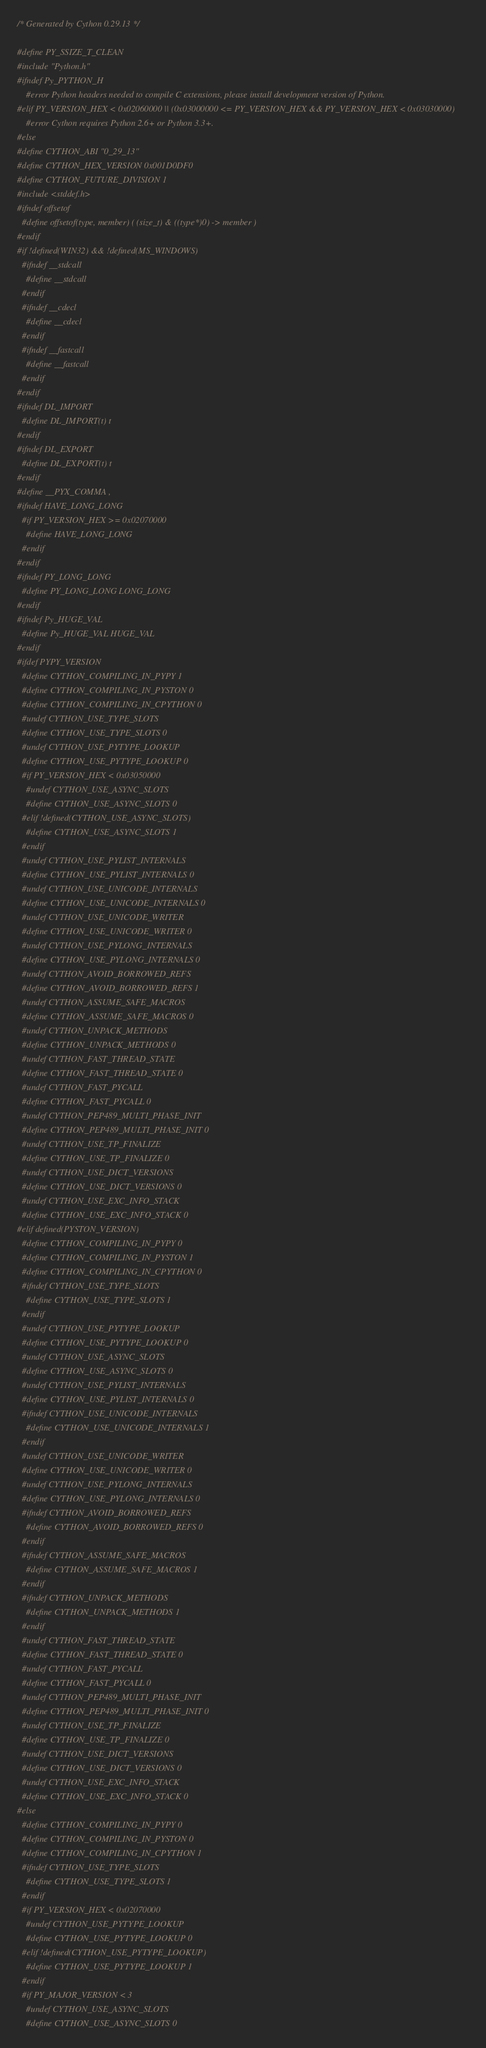Convert code to text. <code><loc_0><loc_0><loc_500><loc_500><_C_>/* Generated by Cython 0.29.13 */

#define PY_SSIZE_T_CLEAN
#include "Python.h"
#ifndef Py_PYTHON_H
    #error Python headers needed to compile C extensions, please install development version of Python.
#elif PY_VERSION_HEX < 0x02060000 || (0x03000000 <= PY_VERSION_HEX && PY_VERSION_HEX < 0x03030000)
    #error Cython requires Python 2.6+ or Python 3.3+.
#else
#define CYTHON_ABI "0_29_13"
#define CYTHON_HEX_VERSION 0x001D0DF0
#define CYTHON_FUTURE_DIVISION 1
#include <stddef.h>
#ifndef offsetof
  #define offsetof(type, member) ( (size_t) & ((type*)0) -> member )
#endif
#if !defined(WIN32) && !defined(MS_WINDOWS)
  #ifndef __stdcall
    #define __stdcall
  #endif
  #ifndef __cdecl
    #define __cdecl
  #endif
  #ifndef __fastcall
    #define __fastcall
  #endif
#endif
#ifndef DL_IMPORT
  #define DL_IMPORT(t) t
#endif
#ifndef DL_EXPORT
  #define DL_EXPORT(t) t
#endif
#define __PYX_COMMA ,
#ifndef HAVE_LONG_LONG
  #if PY_VERSION_HEX >= 0x02070000
    #define HAVE_LONG_LONG
  #endif
#endif
#ifndef PY_LONG_LONG
  #define PY_LONG_LONG LONG_LONG
#endif
#ifndef Py_HUGE_VAL
  #define Py_HUGE_VAL HUGE_VAL
#endif
#ifdef PYPY_VERSION
  #define CYTHON_COMPILING_IN_PYPY 1
  #define CYTHON_COMPILING_IN_PYSTON 0
  #define CYTHON_COMPILING_IN_CPYTHON 0
  #undef CYTHON_USE_TYPE_SLOTS
  #define CYTHON_USE_TYPE_SLOTS 0
  #undef CYTHON_USE_PYTYPE_LOOKUP
  #define CYTHON_USE_PYTYPE_LOOKUP 0
  #if PY_VERSION_HEX < 0x03050000
    #undef CYTHON_USE_ASYNC_SLOTS
    #define CYTHON_USE_ASYNC_SLOTS 0
  #elif !defined(CYTHON_USE_ASYNC_SLOTS)
    #define CYTHON_USE_ASYNC_SLOTS 1
  #endif
  #undef CYTHON_USE_PYLIST_INTERNALS
  #define CYTHON_USE_PYLIST_INTERNALS 0
  #undef CYTHON_USE_UNICODE_INTERNALS
  #define CYTHON_USE_UNICODE_INTERNALS 0
  #undef CYTHON_USE_UNICODE_WRITER
  #define CYTHON_USE_UNICODE_WRITER 0
  #undef CYTHON_USE_PYLONG_INTERNALS
  #define CYTHON_USE_PYLONG_INTERNALS 0
  #undef CYTHON_AVOID_BORROWED_REFS
  #define CYTHON_AVOID_BORROWED_REFS 1
  #undef CYTHON_ASSUME_SAFE_MACROS
  #define CYTHON_ASSUME_SAFE_MACROS 0
  #undef CYTHON_UNPACK_METHODS
  #define CYTHON_UNPACK_METHODS 0
  #undef CYTHON_FAST_THREAD_STATE
  #define CYTHON_FAST_THREAD_STATE 0
  #undef CYTHON_FAST_PYCALL
  #define CYTHON_FAST_PYCALL 0
  #undef CYTHON_PEP489_MULTI_PHASE_INIT
  #define CYTHON_PEP489_MULTI_PHASE_INIT 0
  #undef CYTHON_USE_TP_FINALIZE
  #define CYTHON_USE_TP_FINALIZE 0
  #undef CYTHON_USE_DICT_VERSIONS
  #define CYTHON_USE_DICT_VERSIONS 0
  #undef CYTHON_USE_EXC_INFO_STACK
  #define CYTHON_USE_EXC_INFO_STACK 0
#elif defined(PYSTON_VERSION)
  #define CYTHON_COMPILING_IN_PYPY 0
  #define CYTHON_COMPILING_IN_PYSTON 1
  #define CYTHON_COMPILING_IN_CPYTHON 0
  #ifndef CYTHON_USE_TYPE_SLOTS
    #define CYTHON_USE_TYPE_SLOTS 1
  #endif
  #undef CYTHON_USE_PYTYPE_LOOKUP
  #define CYTHON_USE_PYTYPE_LOOKUP 0
  #undef CYTHON_USE_ASYNC_SLOTS
  #define CYTHON_USE_ASYNC_SLOTS 0
  #undef CYTHON_USE_PYLIST_INTERNALS
  #define CYTHON_USE_PYLIST_INTERNALS 0
  #ifndef CYTHON_USE_UNICODE_INTERNALS
    #define CYTHON_USE_UNICODE_INTERNALS 1
  #endif
  #undef CYTHON_USE_UNICODE_WRITER
  #define CYTHON_USE_UNICODE_WRITER 0
  #undef CYTHON_USE_PYLONG_INTERNALS
  #define CYTHON_USE_PYLONG_INTERNALS 0
  #ifndef CYTHON_AVOID_BORROWED_REFS
    #define CYTHON_AVOID_BORROWED_REFS 0
  #endif
  #ifndef CYTHON_ASSUME_SAFE_MACROS
    #define CYTHON_ASSUME_SAFE_MACROS 1
  #endif
  #ifndef CYTHON_UNPACK_METHODS
    #define CYTHON_UNPACK_METHODS 1
  #endif
  #undef CYTHON_FAST_THREAD_STATE
  #define CYTHON_FAST_THREAD_STATE 0
  #undef CYTHON_FAST_PYCALL
  #define CYTHON_FAST_PYCALL 0
  #undef CYTHON_PEP489_MULTI_PHASE_INIT
  #define CYTHON_PEP489_MULTI_PHASE_INIT 0
  #undef CYTHON_USE_TP_FINALIZE
  #define CYTHON_USE_TP_FINALIZE 0
  #undef CYTHON_USE_DICT_VERSIONS
  #define CYTHON_USE_DICT_VERSIONS 0
  #undef CYTHON_USE_EXC_INFO_STACK
  #define CYTHON_USE_EXC_INFO_STACK 0
#else
  #define CYTHON_COMPILING_IN_PYPY 0
  #define CYTHON_COMPILING_IN_PYSTON 0
  #define CYTHON_COMPILING_IN_CPYTHON 1
  #ifndef CYTHON_USE_TYPE_SLOTS
    #define CYTHON_USE_TYPE_SLOTS 1
  #endif
  #if PY_VERSION_HEX < 0x02070000
    #undef CYTHON_USE_PYTYPE_LOOKUP
    #define CYTHON_USE_PYTYPE_LOOKUP 0
  #elif !defined(CYTHON_USE_PYTYPE_LOOKUP)
    #define CYTHON_USE_PYTYPE_LOOKUP 1
  #endif
  #if PY_MAJOR_VERSION < 3
    #undef CYTHON_USE_ASYNC_SLOTS
    #define CYTHON_USE_ASYNC_SLOTS 0</code> 